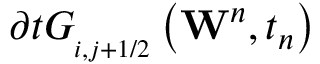<formula> <loc_0><loc_0><loc_500><loc_500>\partial t G _ { _ { i , j + 1 / 2 } } \left ( { { W } ^ { n } } , { { t } _ { n } } \right )</formula> 